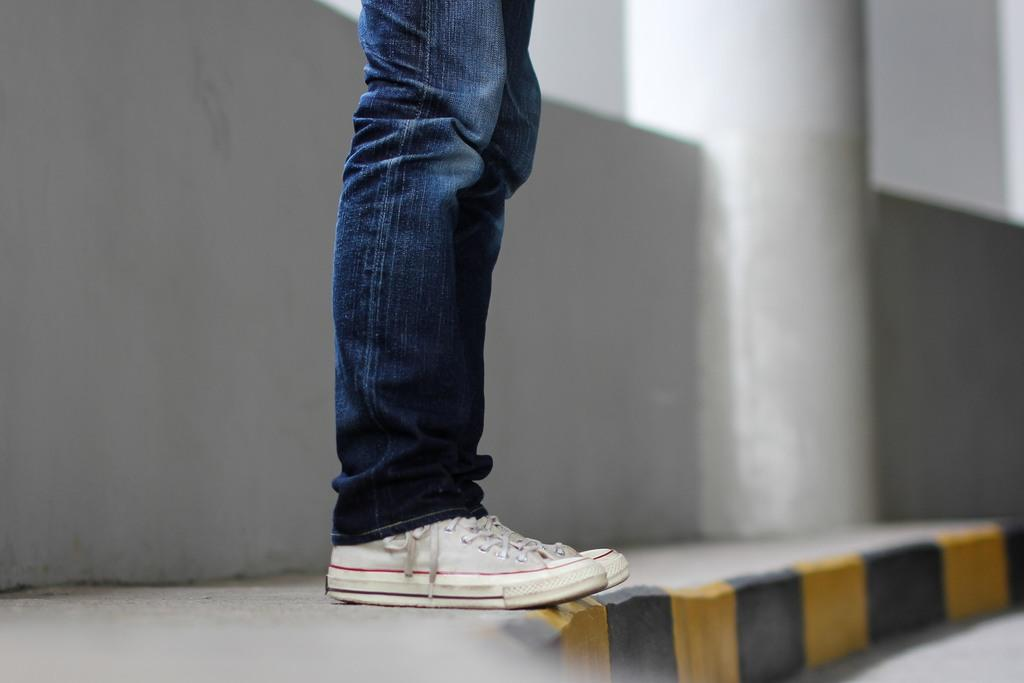What is the main subject of the image? There is a man in the image. What type of clothing is the man wearing? The man is wearing jeans and white shoes. What can be seen at the bottom of the image? There is a road at the bottom of the image. What is located to the left of the image? There is a pavement and a wall to the left of the image. What type of structure is the man using to support his reason for being in the image? There is no structure or reason mentioned in the image; it simply shows a man wearing jeans and white shoes, standing near a road and a wall. 